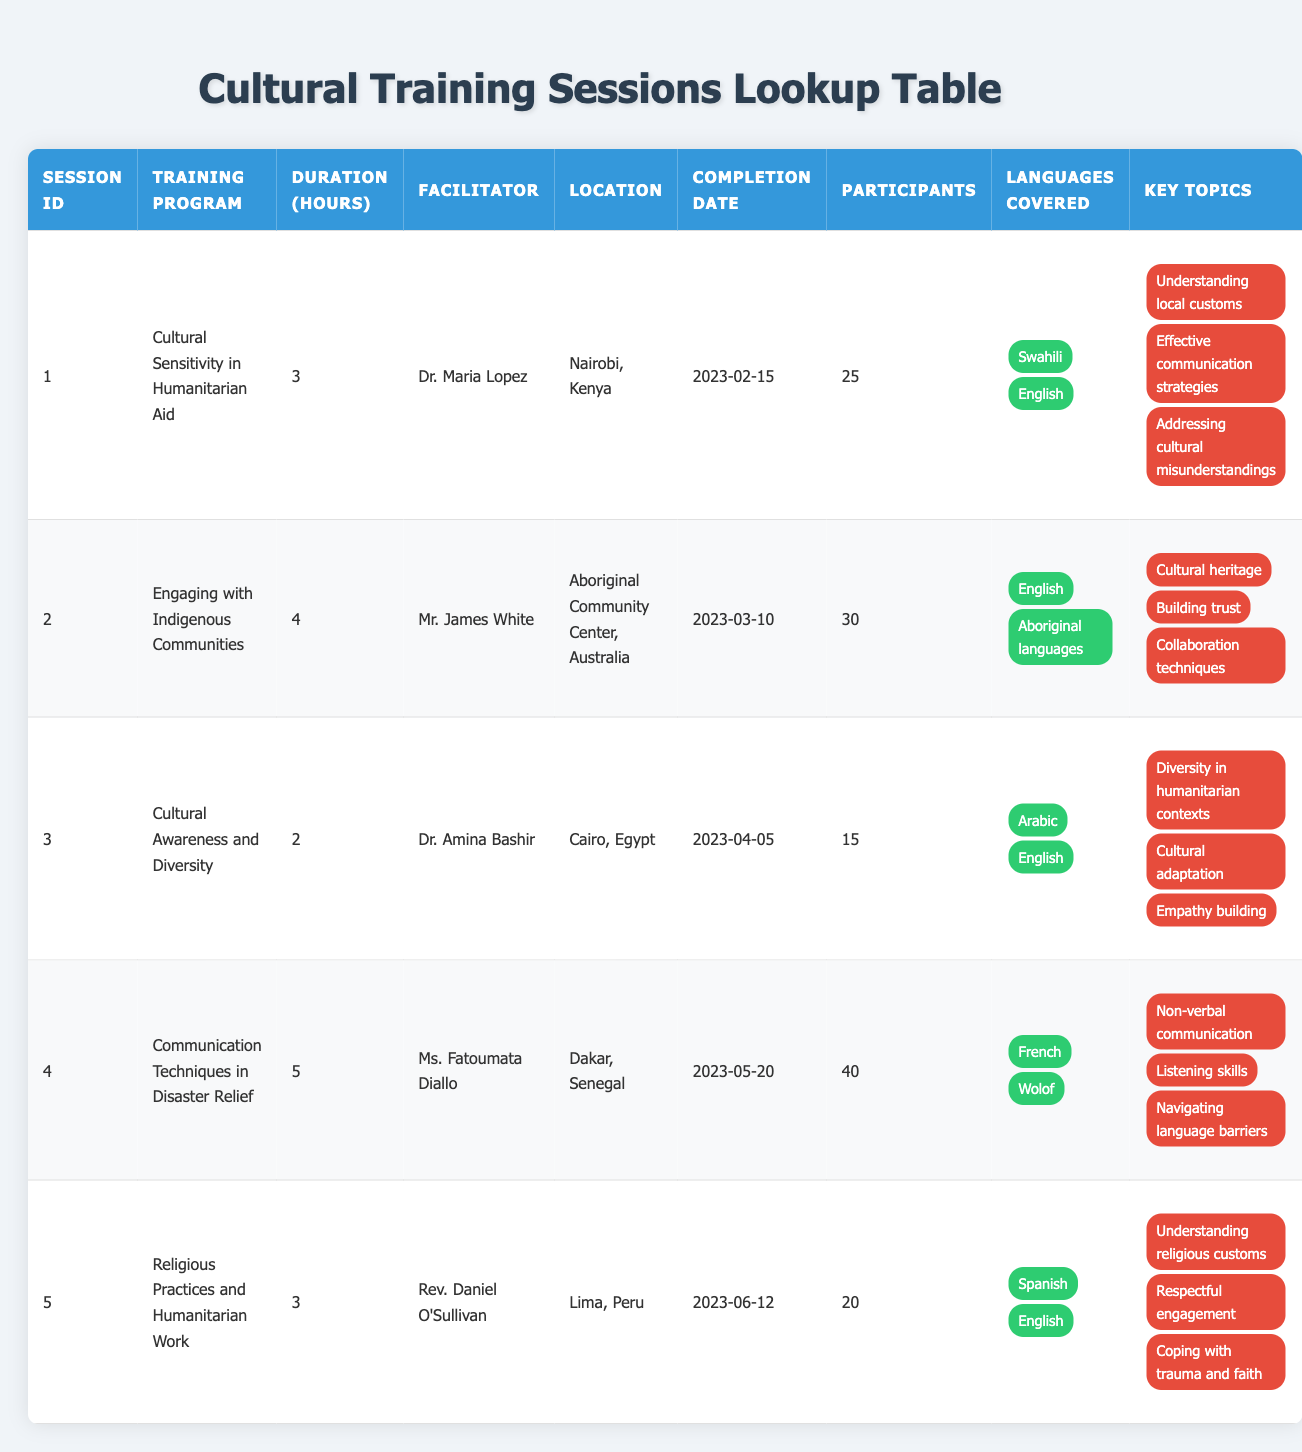What is the duration of the session titled "Cultural Awareness and Diversity"? The table lists the session titled "Cultural Awareness and Diversity" in row 3. The duration of this session is indicated in the "Duration (Hours)" column, which shows a value of 2.
Answer: 2 Who facilitated the training program "Religious Practices and Humanitarian Work"? The table shows that the facilitator's name for the training program "Religious Practices and Humanitarian Work" is listed in row 5 under the "Facilitator" column, which is Rev. Daniel O'Sullivan.
Answer: Rev. Daniel O'Sullivan How many participants attended the session on "Communication Techniques in Disaster Relief"? In the table, the "Communication Techniques in Disaster Relief" session is found in row 4. The number of participants is provided in the "Participants" column, which lists 40 attendees.
Answer: 40 Is the training program "Engaging with Indigenous Communities" longer than 3 hours? The duration for the "Engaging with Indigenous Communities" training program, found in row 2, is specified as 4 hours in the "Duration (Hours)" column. Since 4 is greater than 3, the answer is yes.
Answer: Yes What is the total number of participants across all training sessions? To find the total participants, I add the values from the "Participants" column: 25 (session 1) + 30 (session 2) + 15 (session 3) + 40 (session 4) + 20 (session 5) = 130. This is a sum operation over five data points.
Answer: 130 Which session had the least number of participants, and what was the number? Checking the number of participants in each session, I see that "Cultural Awareness and Diversity" has the least number with 15 participants listed, which is less than others (40, 30, 25, and 20). Thus, the session with the least number of participants is identified.
Answer: Cultural Awareness and Diversity, 15 How many languages were covered in the session titled "Cultural Sensitivity in Humanitarian Aid"? In the row for "Cultural Sensitivity in Humanitarian Aid," we can see the "Languages Covered" section. There are two languages listed: Swahili and English, indicating there were two languages covered in the session.
Answer: 2 Did the "Communication Techniques in Disaster Relief" session cover Wolof? The "Communication Techniques in Disaster Relief" session, on row 4, has the languages listed as "French" and "Wolof." Since Wolof is explicitly mentioned, the answer is yes.
Answer: Yes Which facilitator conducted the session with the maximum number of participants, and how many participants were there? Looking through the participant numbers, "Communication Techniques in Disaster Relief" had the maximum with 40 participants, facilitated by Ms. Fatoumata Diallo. The steps include scanning the table and comparing participant numbers across rows.
Answer: Ms. Fatoumata Diallo, 40 